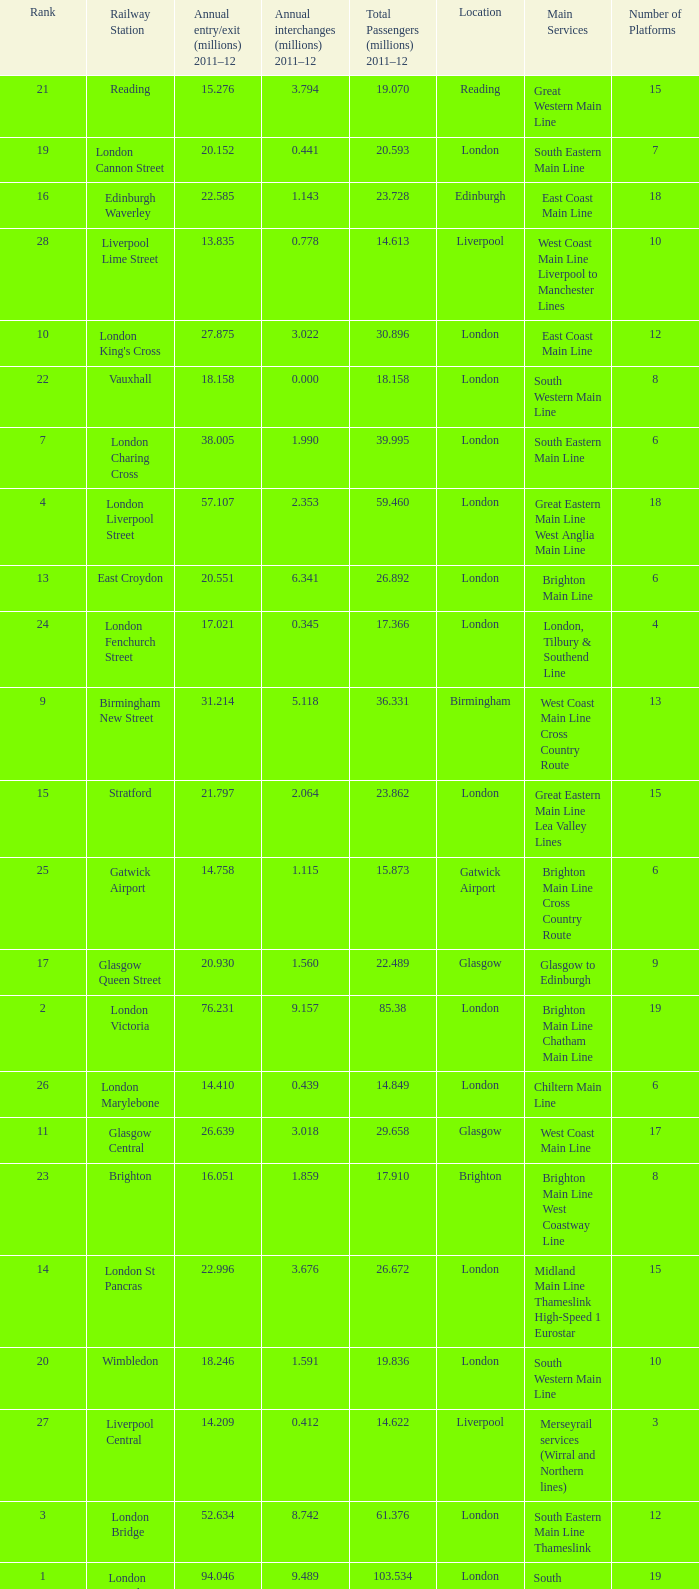Which location has 103.534 million passengers in 2011-12?  London. 